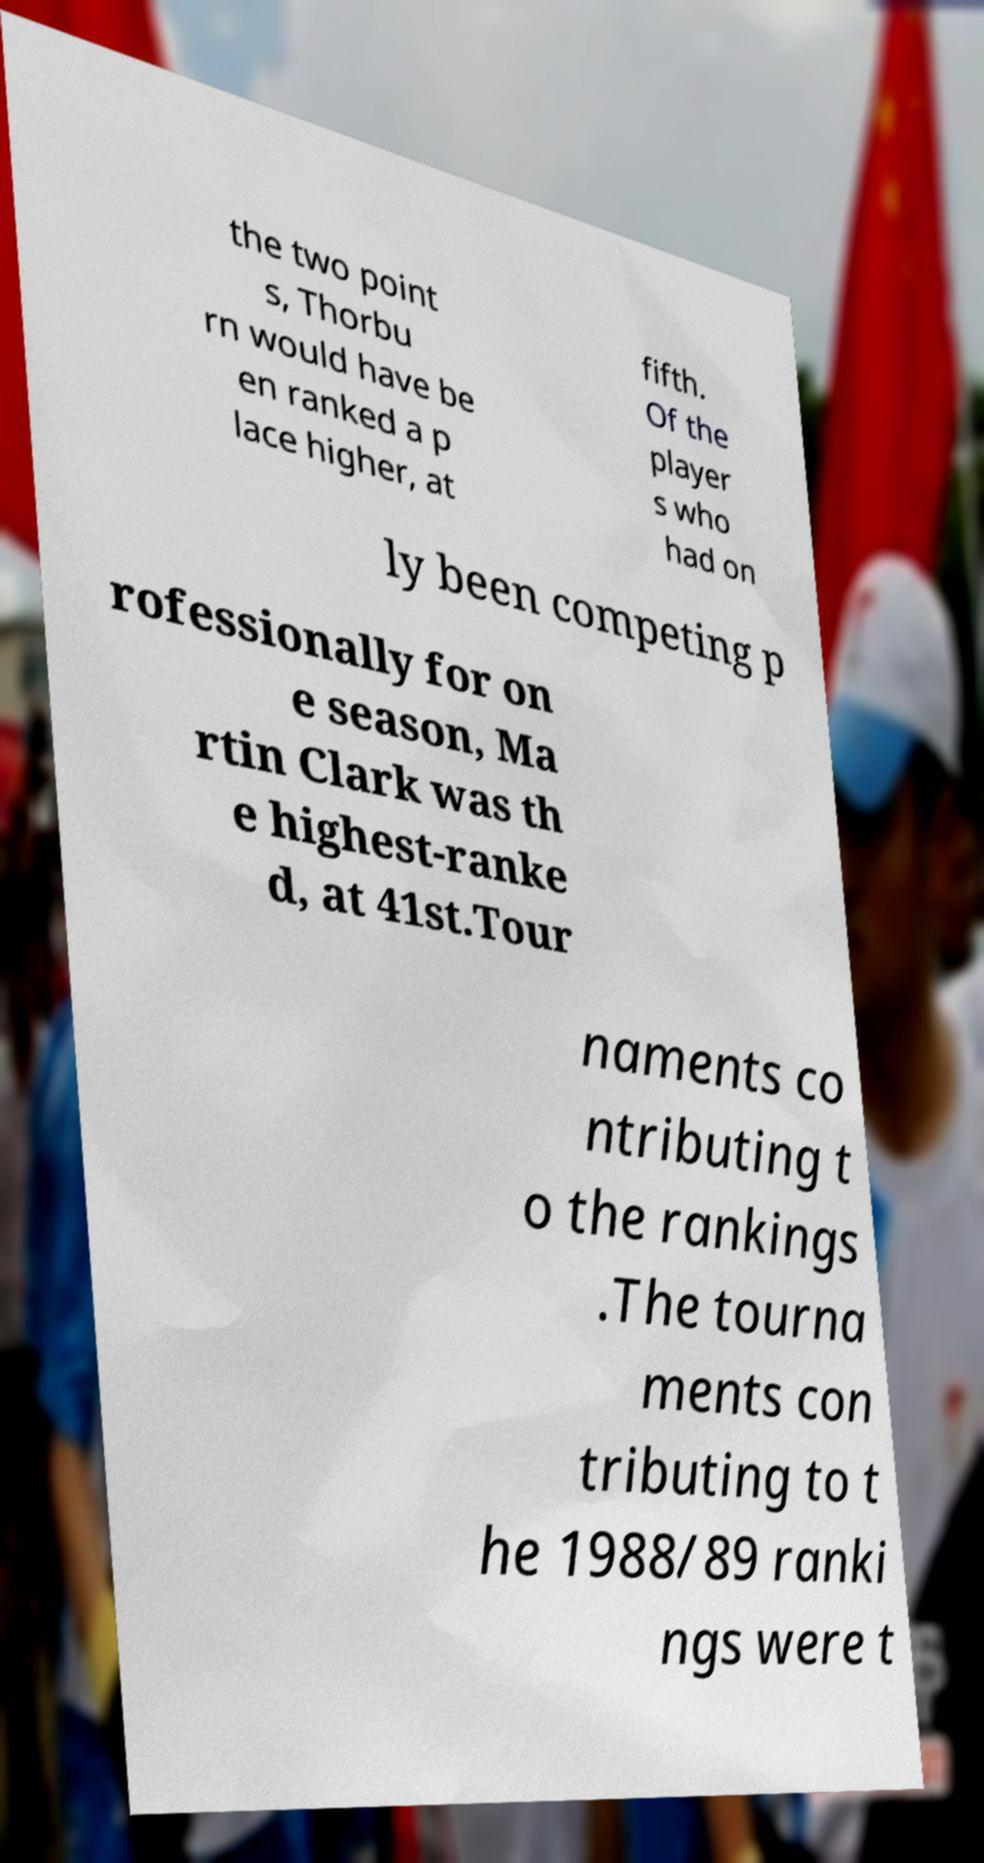Could you assist in decoding the text presented in this image and type it out clearly? the two point s, Thorbu rn would have be en ranked a p lace higher, at fifth. Of the player s who had on ly been competing p rofessionally for on e season, Ma rtin Clark was th e highest-ranke d, at 41st.Tour naments co ntributing t o the rankings .The tourna ments con tributing to t he 1988/89 ranki ngs were t 